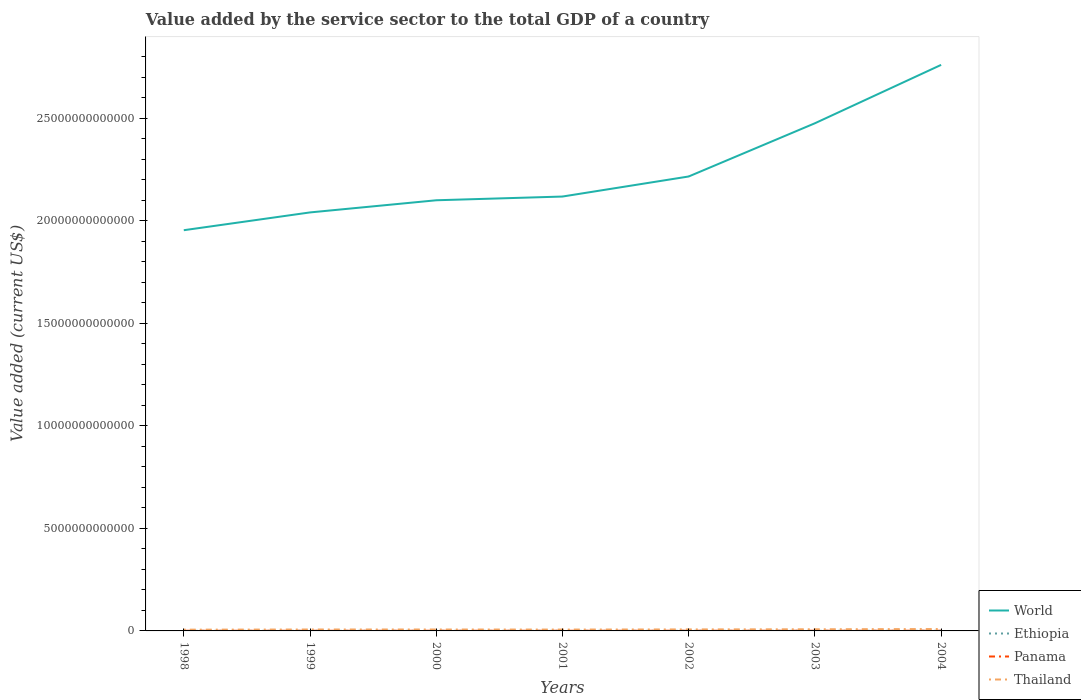Does the line corresponding to World intersect with the line corresponding to Ethiopia?
Give a very brief answer. No. Across all years, what is the maximum value added by the service sector to the total GDP in Thailand?
Make the answer very short. 6.08e+1. What is the total value added by the service sector to the total GDP in World in the graph?
Provide a succinct answer. -7.20e+12. What is the difference between the highest and the second highest value added by the service sector to the total GDP in Panama?
Offer a terse response. 1.53e+09. How many years are there in the graph?
Your answer should be compact. 7. What is the difference between two consecutive major ticks on the Y-axis?
Your response must be concise. 5.00e+12. How many legend labels are there?
Offer a very short reply. 4. What is the title of the graph?
Make the answer very short. Value added by the service sector to the total GDP of a country. What is the label or title of the Y-axis?
Offer a very short reply. Value added (current US$). What is the Value added (current US$) in World in 1998?
Make the answer very short. 1.95e+13. What is the Value added (current US$) of Ethiopia in 1998?
Keep it short and to the point. 2.57e+09. What is the Value added (current US$) of Panama in 1998?
Keep it short and to the point. 7.54e+09. What is the Value added (current US$) of Thailand in 1998?
Keep it short and to the point. 6.08e+1. What is the Value added (current US$) of World in 1999?
Your answer should be compact. 2.04e+13. What is the Value added (current US$) in Ethiopia in 1999?
Your answer should be very brief. 2.76e+09. What is the Value added (current US$) of Panama in 1999?
Ensure brevity in your answer.  7.82e+09. What is the Value added (current US$) in Thailand in 1999?
Provide a short and direct response. 6.91e+1. What is the Value added (current US$) in World in 2000?
Your response must be concise. 2.10e+13. What is the Value added (current US$) in Ethiopia in 2000?
Offer a very short reply. 3.09e+09. What is the Value added (current US$) of Panama in 2000?
Provide a short and direct response. 8.08e+09. What is the Value added (current US$) of Thailand in 2000?
Your answer should be very brief. 6.91e+1. What is the Value added (current US$) in World in 2001?
Ensure brevity in your answer.  2.12e+13. What is the Value added (current US$) in Ethiopia in 2001?
Your answer should be compact. 3.17e+09. What is the Value added (current US$) of Panama in 2001?
Provide a succinct answer. 8.40e+09. What is the Value added (current US$) of Thailand in 2001?
Provide a succinct answer. 6.61e+1. What is the Value added (current US$) in World in 2002?
Your answer should be very brief. 2.22e+13. What is the Value added (current US$) of Ethiopia in 2002?
Offer a very short reply. 3.25e+09. What is the Value added (current US$) in Panama in 2002?
Give a very brief answer. 8.82e+09. What is the Value added (current US$) in Thailand in 2002?
Give a very brief answer. 7.29e+1. What is the Value added (current US$) of World in 2003?
Provide a short and direct response. 2.48e+13. What is the Value added (current US$) of Ethiopia in 2003?
Provide a short and direct response. 3.69e+09. What is the Value added (current US$) of Panama in 2003?
Provide a succinct answer. 9.04e+09. What is the Value added (current US$) in Thailand in 2003?
Your answer should be very brief. 7.99e+1. What is the Value added (current US$) in World in 2004?
Offer a very short reply. 2.76e+13. What is the Value added (current US$) of Ethiopia in 2004?
Offer a terse response. 4.06e+09. What is the Value added (current US$) of Panama in 2004?
Offer a terse response. 9.07e+09. What is the Value added (current US$) in Thailand in 2004?
Offer a terse response. 9.11e+1. Across all years, what is the maximum Value added (current US$) of World?
Your answer should be compact. 2.76e+13. Across all years, what is the maximum Value added (current US$) in Ethiopia?
Offer a terse response. 4.06e+09. Across all years, what is the maximum Value added (current US$) in Panama?
Offer a terse response. 9.07e+09. Across all years, what is the maximum Value added (current US$) in Thailand?
Provide a succinct answer. 9.11e+1. Across all years, what is the minimum Value added (current US$) of World?
Provide a succinct answer. 1.95e+13. Across all years, what is the minimum Value added (current US$) in Ethiopia?
Offer a terse response. 2.57e+09. Across all years, what is the minimum Value added (current US$) in Panama?
Offer a very short reply. 7.54e+09. Across all years, what is the minimum Value added (current US$) of Thailand?
Provide a succinct answer. 6.08e+1. What is the total Value added (current US$) of World in the graph?
Give a very brief answer. 1.57e+14. What is the total Value added (current US$) of Ethiopia in the graph?
Offer a terse response. 2.26e+1. What is the total Value added (current US$) in Panama in the graph?
Your answer should be compact. 5.88e+1. What is the total Value added (current US$) in Thailand in the graph?
Offer a terse response. 5.09e+11. What is the difference between the Value added (current US$) in World in 1998 and that in 1999?
Give a very brief answer. -8.68e+11. What is the difference between the Value added (current US$) in Ethiopia in 1998 and that in 1999?
Offer a very short reply. -1.94e+08. What is the difference between the Value added (current US$) in Panama in 1998 and that in 1999?
Keep it short and to the point. -2.77e+08. What is the difference between the Value added (current US$) in Thailand in 1998 and that in 1999?
Your answer should be compact. -8.34e+09. What is the difference between the Value added (current US$) in World in 1998 and that in 2000?
Give a very brief answer. -1.46e+12. What is the difference between the Value added (current US$) in Ethiopia in 1998 and that in 2000?
Provide a short and direct response. -5.19e+08. What is the difference between the Value added (current US$) of Panama in 1998 and that in 2000?
Keep it short and to the point. -5.33e+08. What is the difference between the Value added (current US$) of Thailand in 1998 and that in 2000?
Provide a short and direct response. -8.32e+09. What is the difference between the Value added (current US$) of World in 1998 and that in 2001?
Offer a terse response. -1.64e+12. What is the difference between the Value added (current US$) of Ethiopia in 1998 and that in 2001?
Provide a succinct answer. -6.01e+08. What is the difference between the Value added (current US$) of Panama in 1998 and that in 2001?
Ensure brevity in your answer.  -8.54e+08. What is the difference between the Value added (current US$) of Thailand in 1998 and that in 2001?
Ensure brevity in your answer.  -5.34e+09. What is the difference between the Value added (current US$) in World in 1998 and that in 2002?
Give a very brief answer. -2.62e+12. What is the difference between the Value added (current US$) of Ethiopia in 1998 and that in 2002?
Your answer should be compact. -6.86e+08. What is the difference between the Value added (current US$) of Panama in 1998 and that in 2002?
Provide a succinct answer. -1.27e+09. What is the difference between the Value added (current US$) of Thailand in 1998 and that in 2002?
Your answer should be compact. -1.21e+1. What is the difference between the Value added (current US$) in World in 1998 and that in 2003?
Make the answer very short. -5.22e+12. What is the difference between the Value added (current US$) of Ethiopia in 1998 and that in 2003?
Offer a very short reply. -1.12e+09. What is the difference between the Value added (current US$) in Panama in 1998 and that in 2003?
Ensure brevity in your answer.  -1.49e+09. What is the difference between the Value added (current US$) of Thailand in 1998 and that in 2003?
Your answer should be compact. -1.92e+1. What is the difference between the Value added (current US$) of World in 1998 and that in 2004?
Your answer should be very brief. -8.07e+12. What is the difference between the Value added (current US$) of Ethiopia in 1998 and that in 2004?
Provide a short and direct response. -1.49e+09. What is the difference between the Value added (current US$) in Panama in 1998 and that in 2004?
Offer a terse response. -1.53e+09. What is the difference between the Value added (current US$) in Thailand in 1998 and that in 2004?
Offer a terse response. -3.03e+1. What is the difference between the Value added (current US$) in World in 1999 and that in 2000?
Your response must be concise. -5.93e+11. What is the difference between the Value added (current US$) of Ethiopia in 1999 and that in 2000?
Provide a short and direct response. -3.25e+08. What is the difference between the Value added (current US$) in Panama in 1999 and that in 2000?
Give a very brief answer. -2.56e+08. What is the difference between the Value added (current US$) in Thailand in 1999 and that in 2000?
Offer a very short reply. 2.30e+07. What is the difference between the Value added (current US$) of World in 1999 and that in 2001?
Your answer should be very brief. -7.75e+11. What is the difference between the Value added (current US$) of Ethiopia in 1999 and that in 2001?
Keep it short and to the point. -4.08e+08. What is the difference between the Value added (current US$) of Panama in 1999 and that in 2001?
Make the answer very short. -5.77e+08. What is the difference between the Value added (current US$) in Thailand in 1999 and that in 2001?
Your answer should be compact. 3.00e+09. What is the difference between the Value added (current US$) of World in 1999 and that in 2002?
Offer a terse response. -1.75e+12. What is the difference between the Value added (current US$) in Ethiopia in 1999 and that in 2002?
Offer a very short reply. -4.92e+08. What is the difference between the Value added (current US$) of Panama in 1999 and that in 2002?
Offer a very short reply. -9.96e+08. What is the difference between the Value added (current US$) in Thailand in 1999 and that in 2002?
Provide a succinct answer. -3.76e+09. What is the difference between the Value added (current US$) in World in 1999 and that in 2003?
Your answer should be very brief. -4.35e+12. What is the difference between the Value added (current US$) in Ethiopia in 1999 and that in 2003?
Give a very brief answer. -9.25e+08. What is the difference between the Value added (current US$) of Panama in 1999 and that in 2003?
Make the answer very short. -1.22e+09. What is the difference between the Value added (current US$) in Thailand in 1999 and that in 2003?
Provide a short and direct response. -1.08e+1. What is the difference between the Value added (current US$) of World in 1999 and that in 2004?
Your response must be concise. -7.20e+12. What is the difference between the Value added (current US$) in Ethiopia in 1999 and that in 2004?
Provide a short and direct response. -1.30e+09. What is the difference between the Value added (current US$) of Panama in 1999 and that in 2004?
Your response must be concise. -1.25e+09. What is the difference between the Value added (current US$) of Thailand in 1999 and that in 2004?
Your answer should be compact. -2.20e+1. What is the difference between the Value added (current US$) in World in 2000 and that in 2001?
Provide a short and direct response. -1.82e+11. What is the difference between the Value added (current US$) of Ethiopia in 2000 and that in 2001?
Your response must be concise. -8.24e+07. What is the difference between the Value added (current US$) in Panama in 2000 and that in 2001?
Give a very brief answer. -3.22e+08. What is the difference between the Value added (current US$) in Thailand in 2000 and that in 2001?
Your response must be concise. 2.98e+09. What is the difference between the Value added (current US$) in World in 2000 and that in 2002?
Offer a very short reply. -1.16e+12. What is the difference between the Value added (current US$) of Ethiopia in 2000 and that in 2002?
Offer a very short reply. -1.67e+08. What is the difference between the Value added (current US$) of Panama in 2000 and that in 2002?
Ensure brevity in your answer.  -7.40e+08. What is the difference between the Value added (current US$) in Thailand in 2000 and that in 2002?
Your answer should be very brief. -3.79e+09. What is the difference between the Value added (current US$) of World in 2000 and that in 2003?
Offer a very short reply. -3.76e+12. What is the difference between the Value added (current US$) in Ethiopia in 2000 and that in 2003?
Make the answer very short. -6.00e+08. What is the difference between the Value added (current US$) in Panama in 2000 and that in 2003?
Keep it short and to the point. -9.62e+08. What is the difference between the Value added (current US$) in Thailand in 2000 and that in 2003?
Give a very brief answer. -1.09e+1. What is the difference between the Value added (current US$) of World in 2000 and that in 2004?
Your response must be concise. -6.60e+12. What is the difference between the Value added (current US$) of Ethiopia in 2000 and that in 2004?
Offer a very short reply. -9.73e+08. What is the difference between the Value added (current US$) in Panama in 2000 and that in 2004?
Your answer should be compact. -9.98e+08. What is the difference between the Value added (current US$) in Thailand in 2000 and that in 2004?
Offer a terse response. -2.20e+1. What is the difference between the Value added (current US$) of World in 2001 and that in 2002?
Give a very brief answer. -9.78e+11. What is the difference between the Value added (current US$) of Ethiopia in 2001 and that in 2002?
Give a very brief answer. -8.46e+07. What is the difference between the Value added (current US$) in Panama in 2001 and that in 2002?
Your response must be concise. -4.18e+08. What is the difference between the Value added (current US$) in Thailand in 2001 and that in 2002?
Offer a very short reply. -6.77e+09. What is the difference between the Value added (current US$) in World in 2001 and that in 2003?
Provide a short and direct response. -3.57e+12. What is the difference between the Value added (current US$) of Ethiopia in 2001 and that in 2003?
Provide a succinct answer. -5.18e+08. What is the difference between the Value added (current US$) of Panama in 2001 and that in 2003?
Offer a terse response. -6.41e+08. What is the difference between the Value added (current US$) in Thailand in 2001 and that in 2003?
Provide a succinct answer. -1.38e+1. What is the difference between the Value added (current US$) in World in 2001 and that in 2004?
Provide a short and direct response. -6.42e+12. What is the difference between the Value added (current US$) of Ethiopia in 2001 and that in 2004?
Your answer should be very brief. -8.91e+08. What is the difference between the Value added (current US$) of Panama in 2001 and that in 2004?
Your answer should be very brief. -6.76e+08. What is the difference between the Value added (current US$) in Thailand in 2001 and that in 2004?
Offer a terse response. -2.50e+1. What is the difference between the Value added (current US$) in World in 2002 and that in 2003?
Provide a short and direct response. -2.60e+12. What is the difference between the Value added (current US$) of Ethiopia in 2002 and that in 2003?
Keep it short and to the point. -4.33e+08. What is the difference between the Value added (current US$) in Panama in 2002 and that in 2003?
Give a very brief answer. -2.22e+08. What is the difference between the Value added (current US$) in Thailand in 2002 and that in 2003?
Make the answer very short. -7.07e+09. What is the difference between the Value added (current US$) in World in 2002 and that in 2004?
Make the answer very short. -5.44e+12. What is the difference between the Value added (current US$) in Ethiopia in 2002 and that in 2004?
Your answer should be compact. -8.06e+08. What is the difference between the Value added (current US$) of Panama in 2002 and that in 2004?
Keep it short and to the point. -2.58e+08. What is the difference between the Value added (current US$) in Thailand in 2002 and that in 2004?
Your response must be concise. -1.82e+1. What is the difference between the Value added (current US$) in World in 2003 and that in 2004?
Your answer should be very brief. -2.85e+12. What is the difference between the Value added (current US$) in Ethiopia in 2003 and that in 2004?
Provide a succinct answer. -3.73e+08. What is the difference between the Value added (current US$) in Panama in 2003 and that in 2004?
Provide a short and direct response. -3.53e+07. What is the difference between the Value added (current US$) in Thailand in 2003 and that in 2004?
Your answer should be compact. -1.11e+1. What is the difference between the Value added (current US$) of World in 1998 and the Value added (current US$) of Ethiopia in 1999?
Keep it short and to the point. 1.95e+13. What is the difference between the Value added (current US$) of World in 1998 and the Value added (current US$) of Panama in 1999?
Your answer should be compact. 1.95e+13. What is the difference between the Value added (current US$) in World in 1998 and the Value added (current US$) in Thailand in 1999?
Your answer should be very brief. 1.95e+13. What is the difference between the Value added (current US$) of Ethiopia in 1998 and the Value added (current US$) of Panama in 1999?
Your answer should be compact. -5.25e+09. What is the difference between the Value added (current US$) of Ethiopia in 1998 and the Value added (current US$) of Thailand in 1999?
Make the answer very short. -6.65e+1. What is the difference between the Value added (current US$) of Panama in 1998 and the Value added (current US$) of Thailand in 1999?
Give a very brief answer. -6.16e+1. What is the difference between the Value added (current US$) of World in 1998 and the Value added (current US$) of Ethiopia in 2000?
Provide a succinct answer. 1.95e+13. What is the difference between the Value added (current US$) in World in 1998 and the Value added (current US$) in Panama in 2000?
Provide a succinct answer. 1.95e+13. What is the difference between the Value added (current US$) of World in 1998 and the Value added (current US$) of Thailand in 2000?
Your response must be concise. 1.95e+13. What is the difference between the Value added (current US$) in Ethiopia in 1998 and the Value added (current US$) in Panama in 2000?
Provide a succinct answer. -5.51e+09. What is the difference between the Value added (current US$) in Ethiopia in 1998 and the Value added (current US$) in Thailand in 2000?
Offer a terse response. -6.65e+1. What is the difference between the Value added (current US$) in Panama in 1998 and the Value added (current US$) in Thailand in 2000?
Your answer should be compact. -6.15e+1. What is the difference between the Value added (current US$) in World in 1998 and the Value added (current US$) in Ethiopia in 2001?
Offer a terse response. 1.95e+13. What is the difference between the Value added (current US$) in World in 1998 and the Value added (current US$) in Panama in 2001?
Your response must be concise. 1.95e+13. What is the difference between the Value added (current US$) in World in 1998 and the Value added (current US$) in Thailand in 2001?
Provide a short and direct response. 1.95e+13. What is the difference between the Value added (current US$) of Ethiopia in 1998 and the Value added (current US$) of Panama in 2001?
Your response must be concise. -5.83e+09. What is the difference between the Value added (current US$) in Ethiopia in 1998 and the Value added (current US$) in Thailand in 2001?
Give a very brief answer. -6.35e+1. What is the difference between the Value added (current US$) in Panama in 1998 and the Value added (current US$) in Thailand in 2001?
Offer a terse response. -5.86e+1. What is the difference between the Value added (current US$) in World in 1998 and the Value added (current US$) in Ethiopia in 2002?
Your answer should be very brief. 1.95e+13. What is the difference between the Value added (current US$) of World in 1998 and the Value added (current US$) of Panama in 2002?
Keep it short and to the point. 1.95e+13. What is the difference between the Value added (current US$) of World in 1998 and the Value added (current US$) of Thailand in 2002?
Ensure brevity in your answer.  1.95e+13. What is the difference between the Value added (current US$) of Ethiopia in 1998 and the Value added (current US$) of Panama in 2002?
Offer a very short reply. -6.25e+09. What is the difference between the Value added (current US$) of Ethiopia in 1998 and the Value added (current US$) of Thailand in 2002?
Your answer should be compact. -7.03e+1. What is the difference between the Value added (current US$) in Panama in 1998 and the Value added (current US$) in Thailand in 2002?
Keep it short and to the point. -6.53e+1. What is the difference between the Value added (current US$) in World in 1998 and the Value added (current US$) in Ethiopia in 2003?
Your answer should be very brief. 1.95e+13. What is the difference between the Value added (current US$) of World in 1998 and the Value added (current US$) of Panama in 2003?
Ensure brevity in your answer.  1.95e+13. What is the difference between the Value added (current US$) in World in 1998 and the Value added (current US$) in Thailand in 2003?
Offer a very short reply. 1.95e+13. What is the difference between the Value added (current US$) of Ethiopia in 1998 and the Value added (current US$) of Panama in 2003?
Your answer should be very brief. -6.47e+09. What is the difference between the Value added (current US$) in Ethiopia in 1998 and the Value added (current US$) in Thailand in 2003?
Your answer should be compact. -7.74e+1. What is the difference between the Value added (current US$) in Panama in 1998 and the Value added (current US$) in Thailand in 2003?
Your answer should be very brief. -7.24e+1. What is the difference between the Value added (current US$) of World in 1998 and the Value added (current US$) of Ethiopia in 2004?
Your answer should be compact. 1.95e+13. What is the difference between the Value added (current US$) in World in 1998 and the Value added (current US$) in Panama in 2004?
Give a very brief answer. 1.95e+13. What is the difference between the Value added (current US$) of World in 1998 and the Value added (current US$) of Thailand in 2004?
Your answer should be compact. 1.95e+13. What is the difference between the Value added (current US$) of Ethiopia in 1998 and the Value added (current US$) of Panama in 2004?
Your answer should be compact. -6.51e+09. What is the difference between the Value added (current US$) of Ethiopia in 1998 and the Value added (current US$) of Thailand in 2004?
Offer a terse response. -8.85e+1. What is the difference between the Value added (current US$) in Panama in 1998 and the Value added (current US$) in Thailand in 2004?
Your answer should be compact. -8.35e+1. What is the difference between the Value added (current US$) of World in 1999 and the Value added (current US$) of Ethiopia in 2000?
Make the answer very short. 2.04e+13. What is the difference between the Value added (current US$) of World in 1999 and the Value added (current US$) of Panama in 2000?
Provide a succinct answer. 2.04e+13. What is the difference between the Value added (current US$) in World in 1999 and the Value added (current US$) in Thailand in 2000?
Your response must be concise. 2.03e+13. What is the difference between the Value added (current US$) in Ethiopia in 1999 and the Value added (current US$) in Panama in 2000?
Your answer should be very brief. -5.32e+09. What is the difference between the Value added (current US$) of Ethiopia in 1999 and the Value added (current US$) of Thailand in 2000?
Your response must be concise. -6.63e+1. What is the difference between the Value added (current US$) of Panama in 1999 and the Value added (current US$) of Thailand in 2000?
Your answer should be compact. -6.13e+1. What is the difference between the Value added (current US$) of World in 1999 and the Value added (current US$) of Ethiopia in 2001?
Provide a succinct answer. 2.04e+13. What is the difference between the Value added (current US$) in World in 1999 and the Value added (current US$) in Panama in 2001?
Offer a terse response. 2.04e+13. What is the difference between the Value added (current US$) in World in 1999 and the Value added (current US$) in Thailand in 2001?
Offer a terse response. 2.03e+13. What is the difference between the Value added (current US$) in Ethiopia in 1999 and the Value added (current US$) in Panama in 2001?
Provide a succinct answer. -5.64e+09. What is the difference between the Value added (current US$) in Ethiopia in 1999 and the Value added (current US$) in Thailand in 2001?
Keep it short and to the point. -6.33e+1. What is the difference between the Value added (current US$) in Panama in 1999 and the Value added (current US$) in Thailand in 2001?
Keep it short and to the point. -5.83e+1. What is the difference between the Value added (current US$) of World in 1999 and the Value added (current US$) of Ethiopia in 2002?
Ensure brevity in your answer.  2.04e+13. What is the difference between the Value added (current US$) in World in 1999 and the Value added (current US$) in Panama in 2002?
Provide a succinct answer. 2.04e+13. What is the difference between the Value added (current US$) in World in 1999 and the Value added (current US$) in Thailand in 2002?
Your response must be concise. 2.03e+13. What is the difference between the Value added (current US$) in Ethiopia in 1999 and the Value added (current US$) in Panama in 2002?
Provide a succinct answer. -6.06e+09. What is the difference between the Value added (current US$) in Ethiopia in 1999 and the Value added (current US$) in Thailand in 2002?
Offer a very short reply. -7.01e+1. What is the difference between the Value added (current US$) of Panama in 1999 and the Value added (current US$) of Thailand in 2002?
Provide a short and direct response. -6.50e+1. What is the difference between the Value added (current US$) of World in 1999 and the Value added (current US$) of Ethiopia in 2003?
Your answer should be compact. 2.04e+13. What is the difference between the Value added (current US$) of World in 1999 and the Value added (current US$) of Panama in 2003?
Give a very brief answer. 2.04e+13. What is the difference between the Value added (current US$) in World in 1999 and the Value added (current US$) in Thailand in 2003?
Provide a succinct answer. 2.03e+13. What is the difference between the Value added (current US$) in Ethiopia in 1999 and the Value added (current US$) in Panama in 2003?
Your answer should be compact. -6.28e+09. What is the difference between the Value added (current US$) in Ethiopia in 1999 and the Value added (current US$) in Thailand in 2003?
Offer a very short reply. -7.72e+1. What is the difference between the Value added (current US$) of Panama in 1999 and the Value added (current US$) of Thailand in 2003?
Offer a terse response. -7.21e+1. What is the difference between the Value added (current US$) of World in 1999 and the Value added (current US$) of Ethiopia in 2004?
Your answer should be very brief. 2.04e+13. What is the difference between the Value added (current US$) of World in 1999 and the Value added (current US$) of Panama in 2004?
Your response must be concise. 2.04e+13. What is the difference between the Value added (current US$) of World in 1999 and the Value added (current US$) of Thailand in 2004?
Offer a terse response. 2.03e+13. What is the difference between the Value added (current US$) of Ethiopia in 1999 and the Value added (current US$) of Panama in 2004?
Keep it short and to the point. -6.31e+09. What is the difference between the Value added (current US$) of Ethiopia in 1999 and the Value added (current US$) of Thailand in 2004?
Make the answer very short. -8.83e+1. What is the difference between the Value added (current US$) in Panama in 1999 and the Value added (current US$) in Thailand in 2004?
Give a very brief answer. -8.33e+1. What is the difference between the Value added (current US$) in World in 2000 and the Value added (current US$) in Ethiopia in 2001?
Your answer should be very brief. 2.10e+13. What is the difference between the Value added (current US$) of World in 2000 and the Value added (current US$) of Panama in 2001?
Offer a terse response. 2.10e+13. What is the difference between the Value added (current US$) in World in 2000 and the Value added (current US$) in Thailand in 2001?
Offer a very short reply. 2.09e+13. What is the difference between the Value added (current US$) of Ethiopia in 2000 and the Value added (current US$) of Panama in 2001?
Make the answer very short. -5.31e+09. What is the difference between the Value added (current US$) in Ethiopia in 2000 and the Value added (current US$) in Thailand in 2001?
Your answer should be compact. -6.30e+1. What is the difference between the Value added (current US$) of Panama in 2000 and the Value added (current US$) of Thailand in 2001?
Provide a succinct answer. -5.80e+1. What is the difference between the Value added (current US$) of World in 2000 and the Value added (current US$) of Ethiopia in 2002?
Keep it short and to the point. 2.10e+13. What is the difference between the Value added (current US$) in World in 2000 and the Value added (current US$) in Panama in 2002?
Provide a short and direct response. 2.10e+13. What is the difference between the Value added (current US$) in World in 2000 and the Value added (current US$) in Thailand in 2002?
Keep it short and to the point. 2.09e+13. What is the difference between the Value added (current US$) in Ethiopia in 2000 and the Value added (current US$) in Panama in 2002?
Give a very brief answer. -5.73e+09. What is the difference between the Value added (current US$) in Ethiopia in 2000 and the Value added (current US$) in Thailand in 2002?
Provide a succinct answer. -6.98e+1. What is the difference between the Value added (current US$) in Panama in 2000 and the Value added (current US$) in Thailand in 2002?
Ensure brevity in your answer.  -6.48e+1. What is the difference between the Value added (current US$) in World in 2000 and the Value added (current US$) in Ethiopia in 2003?
Keep it short and to the point. 2.10e+13. What is the difference between the Value added (current US$) in World in 2000 and the Value added (current US$) in Panama in 2003?
Your answer should be very brief. 2.10e+13. What is the difference between the Value added (current US$) in World in 2000 and the Value added (current US$) in Thailand in 2003?
Your answer should be compact. 2.09e+13. What is the difference between the Value added (current US$) of Ethiopia in 2000 and the Value added (current US$) of Panama in 2003?
Your response must be concise. -5.95e+09. What is the difference between the Value added (current US$) in Ethiopia in 2000 and the Value added (current US$) in Thailand in 2003?
Your answer should be very brief. -7.69e+1. What is the difference between the Value added (current US$) in Panama in 2000 and the Value added (current US$) in Thailand in 2003?
Your answer should be compact. -7.19e+1. What is the difference between the Value added (current US$) of World in 2000 and the Value added (current US$) of Ethiopia in 2004?
Your response must be concise. 2.10e+13. What is the difference between the Value added (current US$) in World in 2000 and the Value added (current US$) in Panama in 2004?
Your answer should be very brief. 2.10e+13. What is the difference between the Value added (current US$) in World in 2000 and the Value added (current US$) in Thailand in 2004?
Your answer should be compact. 2.09e+13. What is the difference between the Value added (current US$) of Ethiopia in 2000 and the Value added (current US$) of Panama in 2004?
Make the answer very short. -5.99e+09. What is the difference between the Value added (current US$) in Ethiopia in 2000 and the Value added (current US$) in Thailand in 2004?
Your answer should be compact. -8.80e+1. What is the difference between the Value added (current US$) in Panama in 2000 and the Value added (current US$) in Thailand in 2004?
Give a very brief answer. -8.30e+1. What is the difference between the Value added (current US$) in World in 2001 and the Value added (current US$) in Ethiopia in 2002?
Make the answer very short. 2.12e+13. What is the difference between the Value added (current US$) of World in 2001 and the Value added (current US$) of Panama in 2002?
Ensure brevity in your answer.  2.12e+13. What is the difference between the Value added (current US$) in World in 2001 and the Value added (current US$) in Thailand in 2002?
Your answer should be compact. 2.11e+13. What is the difference between the Value added (current US$) in Ethiopia in 2001 and the Value added (current US$) in Panama in 2002?
Give a very brief answer. -5.65e+09. What is the difference between the Value added (current US$) of Ethiopia in 2001 and the Value added (current US$) of Thailand in 2002?
Your response must be concise. -6.97e+1. What is the difference between the Value added (current US$) in Panama in 2001 and the Value added (current US$) in Thailand in 2002?
Keep it short and to the point. -6.45e+1. What is the difference between the Value added (current US$) in World in 2001 and the Value added (current US$) in Ethiopia in 2003?
Ensure brevity in your answer.  2.12e+13. What is the difference between the Value added (current US$) in World in 2001 and the Value added (current US$) in Panama in 2003?
Keep it short and to the point. 2.12e+13. What is the difference between the Value added (current US$) of World in 2001 and the Value added (current US$) of Thailand in 2003?
Offer a very short reply. 2.11e+13. What is the difference between the Value added (current US$) in Ethiopia in 2001 and the Value added (current US$) in Panama in 2003?
Provide a short and direct response. -5.87e+09. What is the difference between the Value added (current US$) of Ethiopia in 2001 and the Value added (current US$) of Thailand in 2003?
Offer a terse response. -7.68e+1. What is the difference between the Value added (current US$) in Panama in 2001 and the Value added (current US$) in Thailand in 2003?
Ensure brevity in your answer.  -7.15e+1. What is the difference between the Value added (current US$) of World in 2001 and the Value added (current US$) of Ethiopia in 2004?
Your response must be concise. 2.12e+13. What is the difference between the Value added (current US$) of World in 2001 and the Value added (current US$) of Panama in 2004?
Your answer should be compact. 2.12e+13. What is the difference between the Value added (current US$) in World in 2001 and the Value added (current US$) in Thailand in 2004?
Ensure brevity in your answer.  2.11e+13. What is the difference between the Value added (current US$) in Ethiopia in 2001 and the Value added (current US$) in Panama in 2004?
Your answer should be compact. -5.91e+09. What is the difference between the Value added (current US$) of Ethiopia in 2001 and the Value added (current US$) of Thailand in 2004?
Your response must be concise. -8.79e+1. What is the difference between the Value added (current US$) in Panama in 2001 and the Value added (current US$) in Thailand in 2004?
Provide a succinct answer. -8.27e+1. What is the difference between the Value added (current US$) of World in 2002 and the Value added (current US$) of Ethiopia in 2003?
Give a very brief answer. 2.22e+13. What is the difference between the Value added (current US$) of World in 2002 and the Value added (current US$) of Panama in 2003?
Give a very brief answer. 2.22e+13. What is the difference between the Value added (current US$) in World in 2002 and the Value added (current US$) in Thailand in 2003?
Offer a very short reply. 2.21e+13. What is the difference between the Value added (current US$) of Ethiopia in 2002 and the Value added (current US$) of Panama in 2003?
Make the answer very short. -5.79e+09. What is the difference between the Value added (current US$) of Ethiopia in 2002 and the Value added (current US$) of Thailand in 2003?
Ensure brevity in your answer.  -7.67e+1. What is the difference between the Value added (current US$) of Panama in 2002 and the Value added (current US$) of Thailand in 2003?
Keep it short and to the point. -7.11e+1. What is the difference between the Value added (current US$) of World in 2002 and the Value added (current US$) of Ethiopia in 2004?
Give a very brief answer. 2.22e+13. What is the difference between the Value added (current US$) of World in 2002 and the Value added (current US$) of Panama in 2004?
Give a very brief answer. 2.22e+13. What is the difference between the Value added (current US$) in World in 2002 and the Value added (current US$) in Thailand in 2004?
Provide a short and direct response. 2.21e+13. What is the difference between the Value added (current US$) of Ethiopia in 2002 and the Value added (current US$) of Panama in 2004?
Offer a terse response. -5.82e+09. What is the difference between the Value added (current US$) of Ethiopia in 2002 and the Value added (current US$) of Thailand in 2004?
Make the answer very short. -8.78e+1. What is the difference between the Value added (current US$) of Panama in 2002 and the Value added (current US$) of Thailand in 2004?
Make the answer very short. -8.23e+1. What is the difference between the Value added (current US$) of World in 2003 and the Value added (current US$) of Ethiopia in 2004?
Your answer should be compact. 2.48e+13. What is the difference between the Value added (current US$) in World in 2003 and the Value added (current US$) in Panama in 2004?
Provide a succinct answer. 2.48e+13. What is the difference between the Value added (current US$) in World in 2003 and the Value added (current US$) in Thailand in 2004?
Offer a very short reply. 2.47e+13. What is the difference between the Value added (current US$) in Ethiopia in 2003 and the Value added (current US$) in Panama in 2004?
Make the answer very short. -5.39e+09. What is the difference between the Value added (current US$) of Ethiopia in 2003 and the Value added (current US$) of Thailand in 2004?
Offer a terse response. -8.74e+1. What is the difference between the Value added (current US$) in Panama in 2003 and the Value added (current US$) in Thailand in 2004?
Give a very brief answer. -8.20e+1. What is the average Value added (current US$) in World per year?
Provide a succinct answer. 2.24e+13. What is the average Value added (current US$) of Ethiopia per year?
Offer a terse response. 3.23e+09. What is the average Value added (current US$) in Panama per year?
Ensure brevity in your answer.  8.40e+09. What is the average Value added (current US$) in Thailand per year?
Offer a terse response. 7.27e+1. In the year 1998, what is the difference between the Value added (current US$) of World and Value added (current US$) of Ethiopia?
Your answer should be very brief. 1.95e+13. In the year 1998, what is the difference between the Value added (current US$) of World and Value added (current US$) of Panama?
Your answer should be very brief. 1.95e+13. In the year 1998, what is the difference between the Value added (current US$) of World and Value added (current US$) of Thailand?
Offer a very short reply. 1.95e+13. In the year 1998, what is the difference between the Value added (current US$) of Ethiopia and Value added (current US$) of Panama?
Offer a terse response. -4.98e+09. In the year 1998, what is the difference between the Value added (current US$) of Ethiopia and Value added (current US$) of Thailand?
Your response must be concise. -5.82e+1. In the year 1998, what is the difference between the Value added (current US$) of Panama and Value added (current US$) of Thailand?
Make the answer very short. -5.32e+1. In the year 1999, what is the difference between the Value added (current US$) in World and Value added (current US$) in Ethiopia?
Provide a short and direct response. 2.04e+13. In the year 1999, what is the difference between the Value added (current US$) in World and Value added (current US$) in Panama?
Ensure brevity in your answer.  2.04e+13. In the year 1999, what is the difference between the Value added (current US$) of World and Value added (current US$) of Thailand?
Provide a short and direct response. 2.03e+13. In the year 1999, what is the difference between the Value added (current US$) of Ethiopia and Value added (current US$) of Panama?
Your answer should be compact. -5.06e+09. In the year 1999, what is the difference between the Value added (current US$) in Ethiopia and Value added (current US$) in Thailand?
Your answer should be very brief. -6.63e+1. In the year 1999, what is the difference between the Value added (current US$) in Panama and Value added (current US$) in Thailand?
Keep it short and to the point. -6.13e+1. In the year 2000, what is the difference between the Value added (current US$) of World and Value added (current US$) of Ethiopia?
Your answer should be compact. 2.10e+13. In the year 2000, what is the difference between the Value added (current US$) in World and Value added (current US$) in Panama?
Your answer should be very brief. 2.10e+13. In the year 2000, what is the difference between the Value added (current US$) in World and Value added (current US$) in Thailand?
Offer a very short reply. 2.09e+13. In the year 2000, what is the difference between the Value added (current US$) of Ethiopia and Value added (current US$) of Panama?
Offer a terse response. -4.99e+09. In the year 2000, what is the difference between the Value added (current US$) in Ethiopia and Value added (current US$) in Thailand?
Your answer should be very brief. -6.60e+1. In the year 2000, what is the difference between the Value added (current US$) of Panama and Value added (current US$) of Thailand?
Offer a very short reply. -6.10e+1. In the year 2001, what is the difference between the Value added (current US$) of World and Value added (current US$) of Ethiopia?
Provide a succinct answer. 2.12e+13. In the year 2001, what is the difference between the Value added (current US$) of World and Value added (current US$) of Panama?
Your response must be concise. 2.12e+13. In the year 2001, what is the difference between the Value added (current US$) of World and Value added (current US$) of Thailand?
Your answer should be compact. 2.11e+13. In the year 2001, what is the difference between the Value added (current US$) of Ethiopia and Value added (current US$) of Panama?
Keep it short and to the point. -5.23e+09. In the year 2001, what is the difference between the Value added (current US$) of Ethiopia and Value added (current US$) of Thailand?
Provide a succinct answer. -6.29e+1. In the year 2001, what is the difference between the Value added (current US$) of Panama and Value added (current US$) of Thailand?
Your answer should be very brief. -5.77e+1. In the year 2002, what is the difference between the Value added (current US$) in World and Value added (current US$) in Ethiopia?
Provide a short and direct response. 2.22e+13. In the year 2002, what is the difference between the Value added (current US$) in World and Value added (current US$) in Panama?
Make the answer very short. 2.22e+13. In the year 2002, what is the difference between the Value added (current US$) in World and Value added (current US$) in Thailand?
Offer a terse response. 2.21e+13. In the year 2002, what is the difference between the Value added (current US$) of Ethiopia and Value added (current US$) of Panama?
Your answer should be compact. -5.56e+09. In the year 2002, what is the difference between the Value added (current US$) in Ethiopia and Value added (current US$) in Thailand?
Make the answer very short. -6.96e+1. In the year 2002, what is the difference between the Value added (current US$) of Panama and Value added (current US$) of Thailand?
Offer a very short reply. -6.41e+1. In the year 2003, what is the difference between the Value added (current US$) in World and Value added (current US$) in Ethiopia?
Offer a very short reply. 2.48e+13. In the year 2003, what is the difference between the Value added (current US$) of World and Value added (current US$) of Panama?
Give a very brief answer. 2.48e+13. In the year 2003, what is the difference between the Value added (current US$) of World and Value added (current US$) of Thailand?
Ensure brevity in your answer.  2.47e+13. In the year 2003, what is the difference between the Value added (current US$) in Ethiopia and Value added (current US$) in Panama?
Offer a terse response. -5.35e+09. In the year 2003, what is the difference between the Value added (current US$) in Ethiopia and Value added (current US$) in Thailand?
Offer a terse response. -7.63e+1. In the year 2003, what is the difference between the Value added (current US$) of Panama and Value added (current US$) of Thailand?
Ensure brevity in your answer.  -7.09e+1. In the year 2004, what is the difference between the Value added (current US$) in World and Value added (current US$) in Ethiopia?
Make the answer very short. 2.76e+13. In the year 2004, what is the difference between the Value added (current US$) in World and Value added (current US$) in Panama?
Provide a short and direct response. 2.76e+13. In the year 2004, what is the difference between the Value added (current US$) of World and Value added (current US$) of Thailand?
Keep it short and to the point. 2.75e+13. In the year 2004, what is the difference between the Value added (current US$) in Ethiopia and Value added (current US$) in Panama?
Ensure brevity in your answer.  -5.01e+09. In the year 2004, what is the difference between the Value added (current US$) of Ethiopia and Value added (current US$) of Thailand?
Keep it short and to the point. -8.70e+1. In the year 2004, what is the difference between the Value added (current US$) of Panama and Value added (current US$) of Thailand?
Your answer should be very brief. -8.20e+1. What is the ratio of the Value added (current US$) in World in 1998 to that in 1999?
Give a very brief answer. 0.96. What is the ratio of the Value added (current US$) in Ethiopia in 1998 to that in 1999?
Provide a succinct answer. 0.93. What is the ratio of the Value added (current US$) in Panama in 1998 to that in 1999?
Your response must be concise. 0.96. What is the ratio of the Value added (current US$) in Thailand in 1998 to that in 1999?
Offer a terse response. 0.88. What is the ratio of the Value added (current US$) in World in 1998 to that in 2000?
Offer a very short reply. 0.93. What is the ratio of the Value added (current US$) in Ethiopia in 1998 to that in 2000?
Offer a terse response. 0.83. What is the ratio of the Value added (current US$) in Panama in 1998 to that in 2000?
Your response must be concise. 0.93. What is the ratio of the Value added (current US$) of Thailand in 1998 to that in 2000?
Offer a very short reply. 0.88. What is the ratio of the Value added (current US$) in World in 1998 to that in 2001?
Your answer should be compact. 0.92. What is the ratio of the Value added (current US$) in Ethiopia in 1998 to that in 2001?
Your response must be concise. 0.81. What is the ratio of the Value added (current US$) of Panama in 1998 to that in 2001?
Keep it short and to the point. 0.9. What is the ratio of the Value added (current US$) in Thailand in 1998 to that in 2001?
Make the answer very short. 0.92. What is the ratio of the Value added (current US$) in World in 1998 to that in 2002?
Your answer should be very brief. 0.88. What is the ratio of the Value added (current US$) in Ethiopia in 1998 to that in 2002?
Make the answer very short. 0.79. What is the ratio of the Value added (current US$) of Panama in 1998 to that in 2002?
Offer a terse response. 0.86. What is the ratio of the Value added (current US$) of Thailand in 1998 to that in 2002?
Provide a short and direct response. 0.83. What is the ratio of the Value added (current US$) in World in 1998 to that in 2003?
Give a very brief answer. 0.79. What is the ratio of the Value added (current US$) in Ethiopia in 1998 to that in 2003?
Make the answer very short. 0.7. What is the ratio of the Value added (current US$) of Panama in 1998 to that in 2003?
Keep it short and to the point. 0.83. What is the ratio of the Value added (current US$) of Thailand in 1998 to that in 2003?
Offer a terse response. 0.76. What is the ratio of the Value added (current US$) of World in 1998 to that in 2004?
Your response must be concise. 0.71. What is the ratio of the Value added (current US$) of Ethiopia in 1998 to that in 2004?
Offer a terse response. 0.63. What is the ratio of the Value added (current US$) in Panama in 1998 to that in 2004?
Make the answer very short. 0.83. What is the ratio of the Value added (current US$) of Thailand in 1998 to that in 2004?
Give a very brief answer. 0.67. What is the ratio of the Value added (current US$) in World in 1999 to that in 2000?
Make the answer very short. 0.97. What is the ratio of the Value added (current US$) in Ethiopia in 1999 to that in 2000?
Your answer should be very brief. 0.89. What is the ratio of the Value added (current US$) in Panama in 1999 to that in 2000?
Your answer should be very brief. 0.97. What is the ratio of the Value added (current US$) in Thailand in 1999 to that in 2000?
Ensure brevity in your answer.  1. What is the ratio of the Value added (current US$) of World in 1999 to that in 2001?
Provide a succinct answer. 0.96. What is the ratio of the Value added (current US$) of Ethiopia in 1999 to that in 2001?
Your answer should be very brief. 0.87. What is the ratio of the Value added (current US$) in Panama in 1999 to that in 2001?
Make the answer very short. 0.93. What is the ratio of the Value added (current US$) in Thailand in 1999 to that in 2001?
Offer a very short reply. 1.05. What is the ratio of the Value added (current US$) in World in 1999 to that in 2002?
Make the answer very short. 0.92. What is the ratio of the Value added (current US$) of Ethiopia in 1999 to that in 2002?
Provide a short and direct response. 0.85. What is the ratio of the Value added (current US$) in Panama in 1999 to that in 2002?
Your answer should be very brief. 0.89. What is the ratio of the Value added (current US$) of Thailand in 1999 to that in 2002?
Your answer should be compact. 0.95. What is the ratio of the Value added (current US$) in World in 1999 to that in 2003?
Provide a short and direct response. 0.82. What is the ratio of the Value added (current US$) in Ethiopia in 1999 to that in 2003?
Your response must be concise. 0.75. What is the ratio of the Value added (current US$) in Panama in 1999 to that in 2003?
Provide a short and direct response. 0.87. What is the ratio of the Value added (current US$) of Thailand in 1999 to that in 2003?
Ensure brevity in your answer.  0.86. What is the ratio of the Value added (current US$) of World in 1999 to that in 2004?
Give a very brief answer. 0.74. What is the ratio of the Value added (current US$) of Ethiopia in 1999 to that in 2004?
Your answer should be very brief. 0.68. What is the ratio of the Value added (current US$) in Panama in 1999 to that in 2004?
Ensure brevity in your answer.  0.86. What is the ratio of the Value added (current US$) in Thailand in 1999 to that in 2004?
Offer a terse response. 0.76. What is the ratio of the Value added (current US$) in Ethiopia in 2000 to that in 2001?
Ensure brevity in your answer.  0.97. What is the ratio of the Value added (current US$) of Panama in 2000 to that in 2001?
Your response must be concise. 0.96. What is the ratio of the Value added (current US$) in Thailand in 2000 to that in 2001?
Offer a very short reply. 1.05. What is the ratio of the Value added (current US$) in World in 2000 to that in 2002?
Your answer should be compact. 0.95. What is the ratio of the Value added (current US$) of Ethiopia in 2000 to that in 2002?
Offer a terse response. 0.95. What is the ratio of the Value added (current US$) in Panama in 2000 to that in 2002?
Make the answer very short. 0.92. What is the ratio of the Value added (current US$) of Thailand in 2000 to that in 2002?
Ensure brevity in your answer.  0.95. What is the ratio of the Value added (current US$) of World in 2000 to that in 2003?
Your answer should be compact. 0.85. What is the ratio of the Value added (current US$) in Ethiopia in 2000 to that in 2003?
Provide a short and direct response. 0.84. What is the ratio of the Value added (current US$) in Panama in 2000 to that in 2003?
Give a very brief answer. 0.89. What is the ratio of the Value added (current US$) in Thailand in 2000 to that in 2003?
Your response must be concise. 0.86. What is the ratio of the Value added (current US$) of World in 2000 to that in 2004?
Your response must be concise. 0.76. What is the ratio of the Value added (current US$) in Ethiopia in 2000 to that in 2004?
Keep it short and to the point. 0.76. What is the ratio of the Value added (current US$) of Panama in 2000 to that in 2004?
Provide a short and direct response. 0.89. What is the ratio of the Value added (current US$) in Thailand in 2000 to that in 2004?
Make the answer very short. 0.76. What is the ratio of the Value added (current US$) of World in 2001 to that in 2002?
Your answer should be compact. 0.96. What is the ratio of the Value added (current US$) of Ethiopia in 2001 to that in 2002?
Your answer should be compact. 0.97. What is the ratio of the Value added (current US$) in Panama in 2001 to that in 2002?
Give a very brief answer. 0.95. What is the ratio of the Value added (current US$) of Thailand in 2001 to that in 2002?
Offer a terse response. 0.91. What is the ratio of the Value added (current US$) of World in 2001 to that in 2003?
Keep it short and to the point. 0.86. What is the ratio of the Value added (current US$) in Ethiopia in 2001 to that in 2003?
Your answer should be very brief. 0.86. What is the ratio of the Value added (current US$) of Panama in 2001 to that in 2003?
Offer a very short reply. 0.93. What is the ratio of the Value added (current US$) in Thailand in 2001 to that in 2003?
Your answer should be compact. 0.83. What is the ratio of the Value added (current US$) in World in 2001 to that in 2004?
Offer a terse response. 0.77. What is the ratio of the Value added (current US$) of Ethiopia in 2001 to that in 2004?
Offer a very short reply. 0.78. What is the ratio of the Value added (current US$) in Panama in 2001 to that in 2004?
Ensure brevity in your answer.  0.93. What is the ratio of the Value added (current US$) of Thailand in 2001 to that in 2004?
Your response must be concise. 0.73. What is the ratio of the Value added (current US$) in World in 2002 to that in 2003?
Ensure brevity in your answer.  0.9. What is the ratio of the Value added (current US$) of Ethiopia in 2002 to that in 2003?
Keep it short and to the point. 0.88. What is the ratio of the Value added (current US$) of Panama in 2002 to that in 2003?
Provide a succinct answer. 0.98. What is the ratio of the Value added (current US$) in Thailand in 2002 to that in 2003?
Ensure brevity in your answer.  0.91. What is the ratio of the Value added (current US$) in World in 2002 to that in 2004?
Your answer should be very brief. 0.8. What is the ratio of the Value added (current US$) in Ethiopia in 2002 to that in 2004?
Offer a terse response. 0.8. What is the ratio of the Value added (current US$) of Panama in 2002 to that in 2004?
Provide a short and direct response. 0.97. What is the ratio of the Value added (current US$) of Thailand in 2002 to that in 2004?
Your answer should be compact. 0.8. What is the ratio of the Value added (current US$) of World in 2003 to that in 2004?
Your response must be concise. 0.9. What is the ratio of the Value added (current US$) of Ethiopia in 2003 to that in 2004?
Provide a short and direct response. 0.91. What is the ratio of the Value added (current US$) in Thailand in 2003 to that in 2004?
Keep it short and to the point. 0.88. What is the difference between the highest and the second highest Value added (current US$) in World?
Offer a very short reply. 2.85e+12. What is the difference between the highest and the second highest Value added (current US$) in Ethiopia?
Offer a terse response. 3.73e+08. What is the difference between the highest and the second highest Value added (current US$) of Panama?
Your answer should be compact. 3.53e+07. What is the difference between the highest and the second highest Value added (current US$) of Thailand?
Keep it short and to the point. 1.11e+1. What is the difference between the highest and the lowest Value added (current US$) in World?
Give a very brief answer. 8.07e+12. What is the difference between the highest and the lowest Value added (current US$) in Ethiopia?
Make the answer very short. 1.49e+09. What is the difference between the highest and the lowest Value added (current US$) in Panama?
Keep it short and to the point. 1.53e+09. What is the difference between the highest and the lowest Value added (current US$) of Thailand?
Make the answer very short. 3.03e+1. 